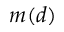Convert formula to latex. <formula><loc_0><loc_0><loc_500><loc_500>m ( d )</formula> 